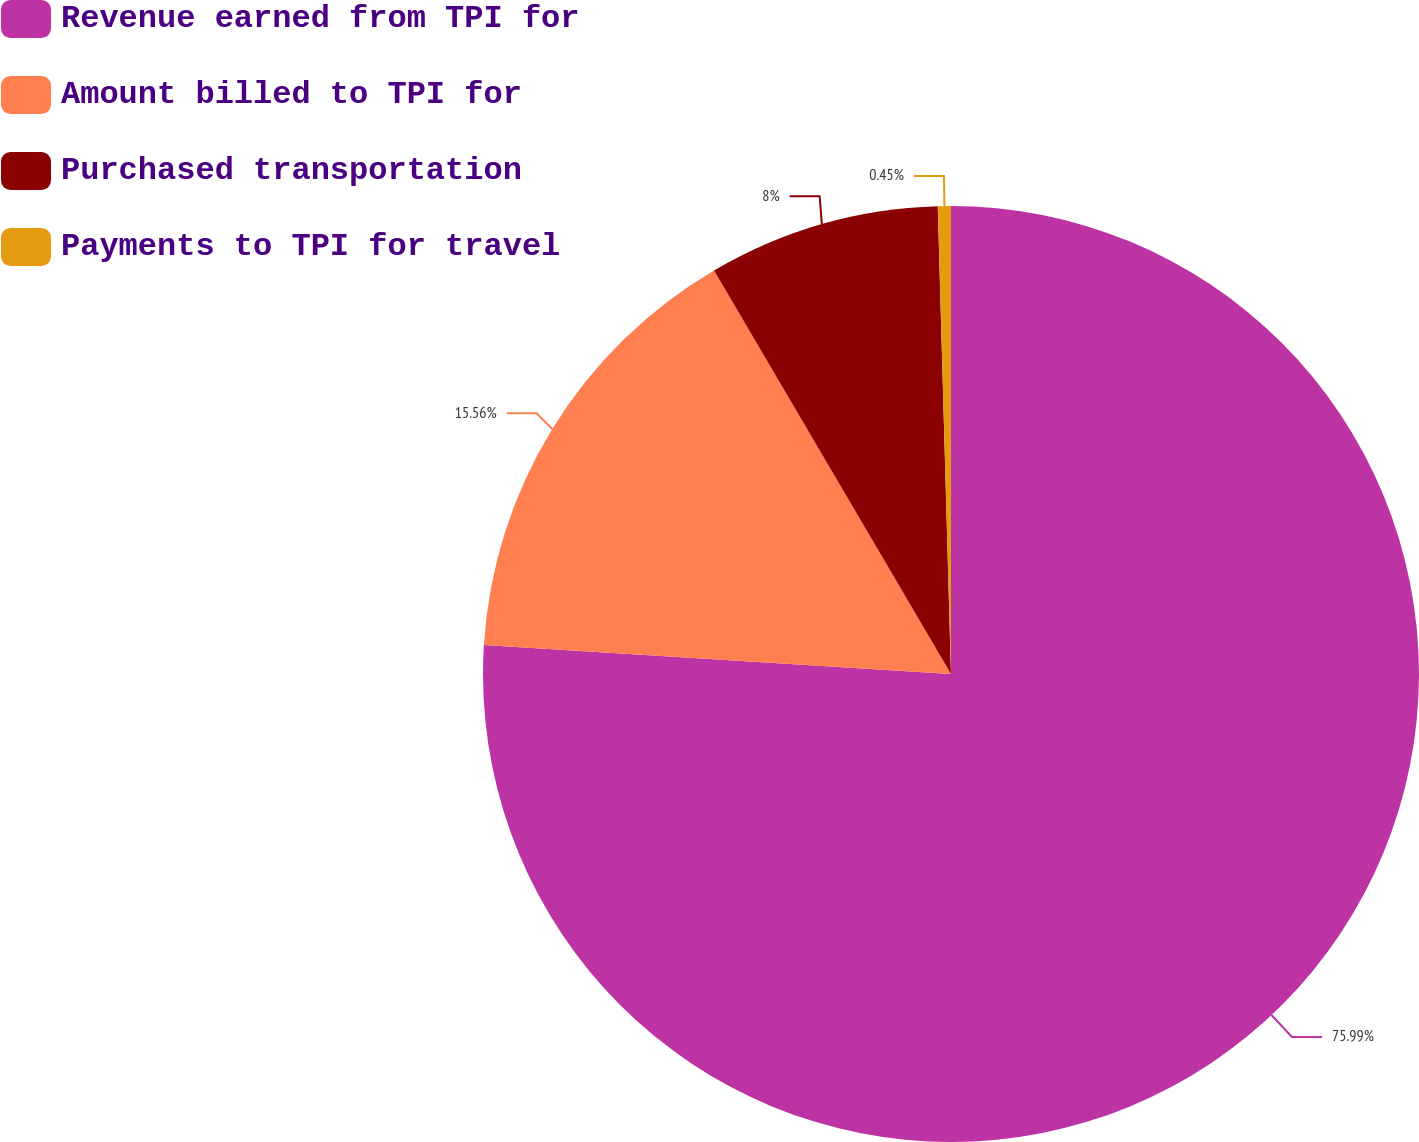Convert chart. <chart><loc_0><loc_0><loc_500><loc_500><pie_chart><fcel>Revenue earned from TPI for<fcel>Amount billed to TPI for<fcel>Purchased transportation<fcel>Payments to TPI for travel<nl><fcel>75.99%<fcel>15.56%<fcel>8.0%<fcel>0.45%<nl></chart> 